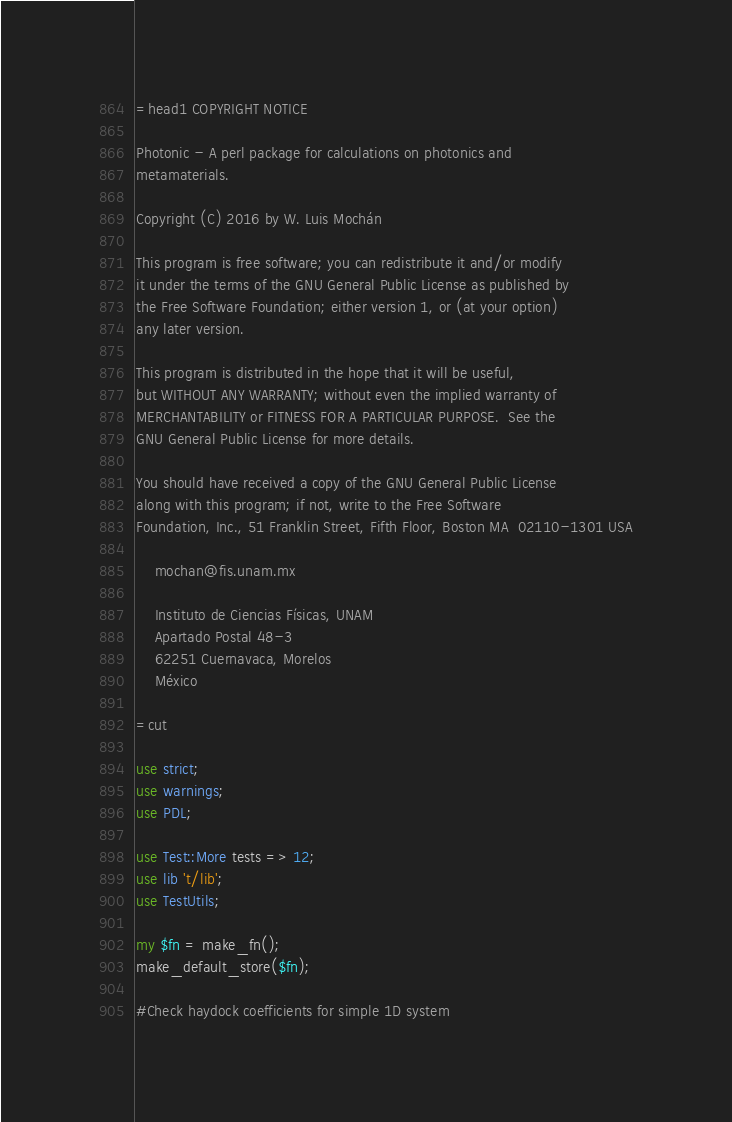<code> <loc_0><loc_0><loc_500><loc_500><_Perl_>=head1 COPYRIGHT NOTICE

Photonic - A perl package for calculations on photonics and
metamaterials.

Copyright (C) 2016 by W. Luis Mochán

This program is free software; you can redistribute it and/or modify
it under the terms of the GNU General Public License as published by
the Free Software Foundation; either version 1, or (at your option)
any later version.

This program is distributed in the hope that it will be useful,
but WITHOUT ANY WARRANTY; without even the implied warranty of
MERCHANTABILITY or FITNESS FOR A PARTICULAR PURPOSE.  See the
GNU General Public License for more details.

You should have received a copy of the GNU General Public License
along with this program; if not, write to the Free Software
Foundation, Inc., 51 Franklin Street, Fifth Floor, Boston MA  02110-1301 USA

    mochan@fis.unam.mx

    Instituto de Ciencias Físicas, UNAM
    Apartado Postal 48-3
    62251 Cuernavaca, Morelos
    México

=cut

use strict;
use warnings;
use PDL;

use Test::More tests => 12;
use lib 't/lib';
use TestUtils;

my $fn = make_fn();
make_default_store($fn);

#Check haydock coefficients for simple 1D system</code> 